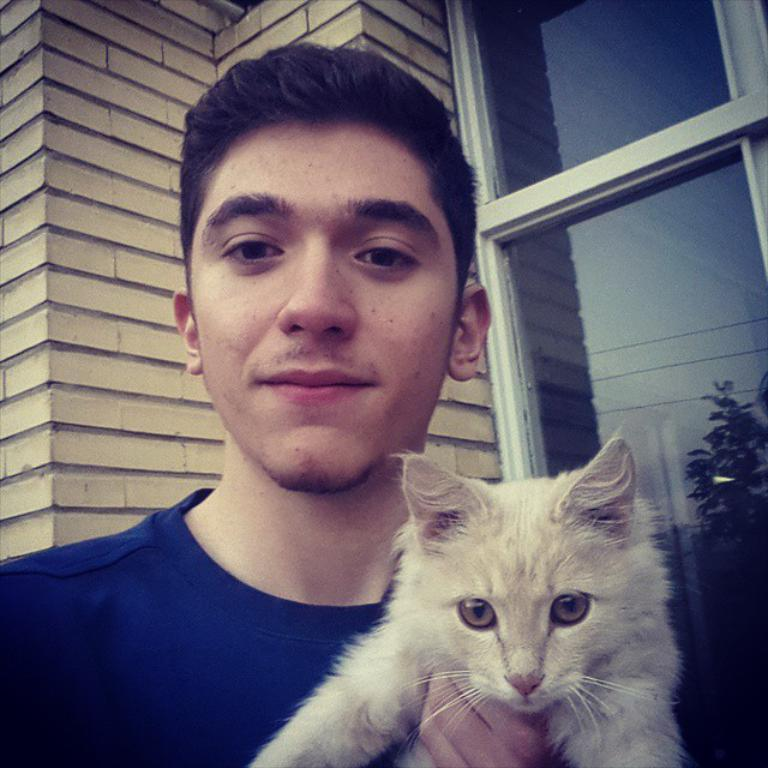Who is the main subject in the image? There is a man standing in the middle of the image. What is the man holding in the image? The man is holding a cat. What is located behind the man in the image? There is a wall behind the man. Where is the glass window in the image? There is a glass window in the top right side of the image. How many cakes are on the coat of the man in the image? There is no mention of cakes or a coat in the image; the man is holding a cat and standing in front of a wall. 